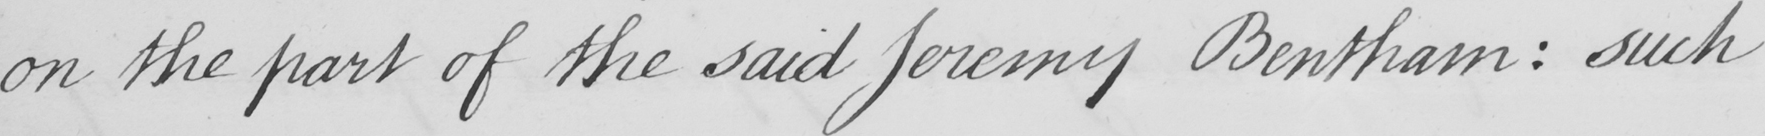What does this handwritten line say? on the part of the said Jeremy Bentham  :  such 